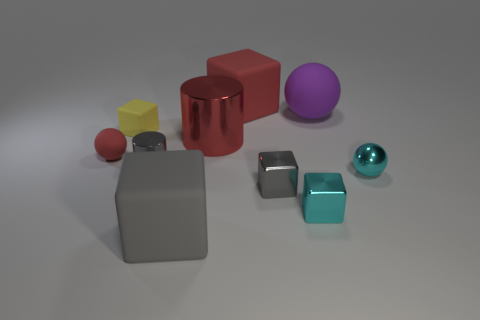There is a red rubber object that is behind the red ball; is its shape the same as the red matte object to the left of the large red rubber object?
Your answer should be compact. No. The small cyan thing right of the rubber sphere behind the shiny cylinder behind the small red sphere is made of what material?
Ensure brevity in your answer.  Metal. The red metallic thing that is the same size as the purple rubber sphere is what shape?
Provide a succinct answer. Cylinder. Are there any other large metallic cylinders of the same color as the big metallic cylinder?
Offer a very short reply. No. The cyan sphere is what size?
Your response must be concise. Small. Are the large cylinder and the yellow cube made of the same material?
Give a very brief answer. No. What number of large rubber balls are left of the big rubber block that is left of the large red object that is in front of the large red cube?
Your answer should be very brief. 0. What is the shape of the metal object that is to the left of the large red cylinder?
Provide a short and direct response. Cylinder. What number of other objects are there of the same material as the tiny yellow thing?
Your answer should be very brief. 4. Is the big metallic cylinder the same color as the tiny shiny ball?
Keep it short and to the point. No. 